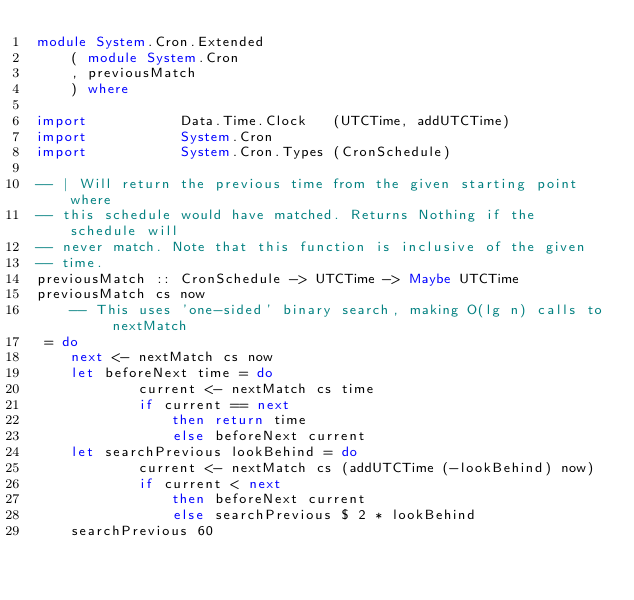<code> <loc_0><loc_0><loc_500><loc_500><_Haskell_>module System.Cron.Extended
    ( module System.Cron
    , previousMatch
    ) where

import           Data.Time.Clock   (UTCTime, addUTCTime)
import           System.Cron
import           System.Cron.Types (CronSchedule)

-- | Will return the previous time from the given starting point where
-- this schedule would have matched. Returns Nothing if the schedule will
-- never match. Note that this function is inclusive of the given
-- time.
previousMatch :: CronSchedule -> UTCTime -> Maybe UTCTime
previousMatch cs now
    -- This uses 'one-sided' binary search, making O(lg n) calls to nextMatch
 = do
    next <- nextMatch cs now
    let beforeNext time = do
            current <- nextMatch cs time
            if current == next
                then return time
                else beforeNext current
    let searchPrevious lookBehind = do
            current <- nextMatch cs (addUTCTime (-lookBehind) now)
            if current < next
                then beforeNext current
                else searchPrevious $ 2 * lookBehind
    searchPrevious 60
</code> 